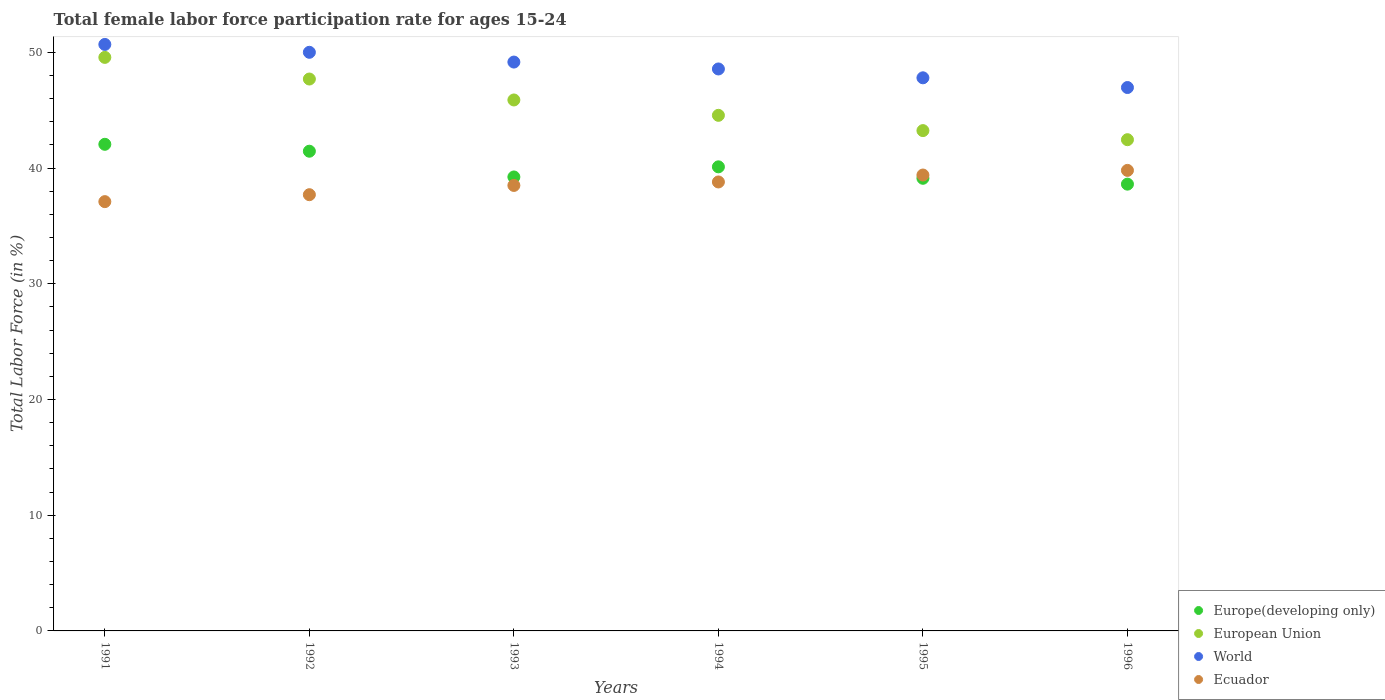What is the female labor force participation rate in Ecuador in 1991?
Offer a terse response. 37.1. Across all years, what is the maximum female labor force participation rate in European Union?
Make the answer very short. 49.57. Across all years, what is the minimum female labor force participation rate in World?
Your answer should be compact. 46.96. What is the total female labor force participation rate in Europe(developing only) in the graph?
Provide a succinct answer. 240.58. What is the difference between the female labor force participation rate in European Union in 1991 and that in 1992?
Make the answer very short. 1.87. What is the difference between the female labor force participation rate in Ecuador in 1993 and the female labor force participation rate in Europe(developing only) in 1994?
Provide a succinct answer. -1.61. What is the average female labor force participation rate in European Union per year?
Provide a short and direct response. 45.57. In the year 1992, what is the difference between the female labor force participation rate in European Union and female labor force participation rate in World?
Keep it short and to the point. -2.31. What is the ratio of the female labor force participation rate in World in 1995 to that in 1996?
Your answer should be compact. 1.02. What is the difference between the highest and the second highest female labor force participation rate in World?
Your answer should be very brief. 0.68. What is the difference between the highest and the lowest female labor force participation rate in European Union?
Give a very brief answer. 7.11. Is it the case that in every year, the sum of the female labor force participation rate in Ecuador and female labor force participation rate in Europe(developing only)  is greater than the sum of female labor force participation rate in World and female labor force participation rate in European Union?
Provide a short and direct response. No. Is it the case that in every year, the sum of the female labor force participation rate in Ecuador and female labor force participation rate in World  is greater than the female labor force participation rate in European Union?
Ensure brevity in your answer.  Yes. Does the female labor force participation rate in European Union monotonically increase over the years?
Your response must be concise. No. Is the female labor force participation rate in World strictly greater than the female labor force participation rate in Ecuador over the years?
Your answer should be compact. Yes. How many dotlines are there?
Ensure brevity in your answer.  4. How many years are there in the graph?
Provide a succinct answer. 6. What is the difference between two consecutive major ticks on the Y-axis?
Ensure brevity in your answer.  10. Does the graph contain any zero values?
Provide a succinct answer. No. How many legend labels are there?
Your answer should be very brief. 4. What is the title of the graph?
Your answer should be very brief. Total female labor force participation rate for ages 15-24. What is the Total Labor Force (in %) in Europe(developing only) in 1991?
Provide a short and direct response. 42.05. What is the Total Labor Force (in %) in European Union in 1991?
Offer a terse response. 49.57. What is the Total Labor Force (in %) in World in 1991?
Your answer should be very brief. 50.69. What is the Total Labor Force (in %) in Ecuador in 1991?
Offer a very short reply. 37.1. What is the Total Labor Force (in %) of Europe(developing only) in 1992?
Your response must be concise. 41.46. What is the Total Labor Force (in %) of European Union in 1992?
Keep it short and to the point. 47.7. What is the Total Labor Force (in %) of World in 1992?
Offer a very short reply. 50.01. What is the Total Labor Force (in %) of Ecuador in 1992?
Keep it short and to the point. 37.7. What is the Total Labor Force (in %) of Europe(developing only) in 1993?
Provide a succinct answer. 39.23. What is the Total Labor Force (in %) of European Union in 1993?
Make the answer very short. 45.89. What is the Total Labor Force (in %) of World in 1993?
Offer a very short reply. 49.16. What is the Total Labor Force (in %) of Ecuador in 1993?
Offer a very short reply. 38.5. What is the Total Labor Force (in %) in Europe(developing only) in 1994?
Give a very brief answer. 40.11. What is the Total Labor Force (in %) of European Union in 1994?
Your answer should be very brief. 44.56. What is the Total Labor Force (in %) in World in 1994?
Your answer should be very brief. 48.57. What is the Total Labor Force (in %) in Ecuador in 1994?
Give a very brief answer. 38.8. What is the Total Labor Force (in %) of Europe(developing only) in 1995?
Your answer should be very brief. 39.12. What is the Total Labor Force (in %) of European Union in 1995?
Your response must be concise. 43.24. What is the Total Labor Force (in %) of World in 1995?
Ensure brevity in your answer.  47.8. What is the Total Labor Force (in %) of Ecuador in 1995?
Your answer should be compact. 39.4. What is the Total Labor Force (in %) of Europe(developing only) in 1996?
Provide a short and direct response. 38.61. What is the Total Labor Force (in %) in European Union in 1996?
Provide a succinct answer. 42.45. What is the Total Labor Force (in %) in World in 1996?
Provide a succinct answer. 46.96. What is the Total Labor Force (in %) of Ecuador in 1996?
Offer a terse response. 39.8. Across all years, what is the maximum Total Labor Force (in %) of Europe(developing only)?
Give a very brief answer. 42.05. Across all years, what is the maximum Total Labor Force (in %) in European Union?
Provide a succinct answer. 49.57. Across all years, what is the maximum Total Labor Force (in %) in World?
Make the answer very short. 50.69. Across all years, what is the maximum Total Labor Force (in %) of Ecuador?
Offer a very short reply. 39.8. Across all years, what is the minimum Total Labor Force (in %) of Europe(developing only)?
Offer a very short reply. 38.61. Across all years, what is the minimum Total Labor Force (in %) of European Union?
Provide a short and direct response. 42.45. Across all years, what is the minimum Total Labor Force (in %) in World?
Ensure brevity in your answer.  46.96. Across all years, what is the minimum Total Labor Force (in %) of Ecuador?
Your answer should be very brief. 37.1. What is the total Total Labor Force (in %) of Europe(developing only) in the graph?
Keep it short and to the point. 240.58. What is the total Total Labor Force (in %) of European Union in the graph?
Your response must be concise. 273.4. What is the total Total Labor Force (in %) of World in the graph?
Your response must be concise. 293.18. What is the total Total Labor Force (in %) of Ecuador in the graph?
Provide a short and direct response. 231.3. What is the difference between the Total Labor Force (in %) in Europe(developing only) in 1991 and that in 1992?
Your answer should be very brief. 0.6. What is the difference between the Total Labor Force (in %) of European Union in 1991 and that in 1992?
Your answer should be compact. 1.87. What is the difference between the Total Labor Force (in %) of World in 1991 and that in 1992?
Offer a very short reply. 0.68. What is the difference between the Total Labor Force (in %) in Europe(developing only) in 1991 and that in 1993?
Ensure brevity in your answer.  2.82. What is the difference between the Total Labor Force (in %) in European Union in 1991 and that in 1993?
Give a very brief answer. 3.68. What is the difference between the Total Labor Force (in %) of World in 1991 and that in 1993?
Ensure brevity in your answer.  1.52. What is the difference between the Total Labor Force (in %) of Europe(developing only) in 1991 and that in 1994?
Make the answer very short. 1.95. What is the difference between the Total Labor Force (in %) in European Union in 1991 and that in 1994?
Your answer should be compact. 5.01. What is the difference between the Total Labor Force (in %) of World in 1991 and that in 1994?
Ensure brevity in your answer.  2.12. What is the difference between the Total Labor Force (in %) in Europe(developing only) in 1991 and that in 1995?
Offer a very short reply. 2.94. What is the difference between the Total Labor Force (in %) in European Union in 1991 and that in 1995?
Provide a short and direct response. 6.33. What is the difference between the Total Labor Force (in %) of World in 1991 and that in 1995?
Keep it short and to the point. 2.88. What is the difference between the Total Labor Force (in %) in Europe(developing only) in 1991 and that in 1996?
Offer a terse response. 3.44. What is the difference between the Total Labor Force (in %) of European Union in 1991 and that in 1996?
Offer a very short reply. 7.11. What is the difference between the Total Labor Force (in %) of World in 1991 and that in 1996?
Provide a succinct answer. 3.72. What is the difference between the Total Labor Force (in %) in Ecuador in 1991 and that in 1996?
Make the answer very short. -2.7. What is the difference between the Total Labor Force (in %) in Europe(developing only) in 1992 and that in 1993?
Provide a succinct answer. 2.23. What is the difference between the Total Labor Force (in %) in European Union in 1992 and that in 1993?
Ensure brevity in your answer.  1.81. What is the difference between the Total Labor Force (in %) in World in 1992 and that in 1993?
Your answer should be compact. 0.84. What is the difference between the Total Labor Force (in %) in Europe(developing only) in 1992 and that in 1994?
Your answer should be compact. 1.35. What is the difference between the Total Labor Force (in %) of European Union in 1992 and that in 1994?
Provide a short and direct response. 3.14. What is the difference between the Total Labor Force (in %) of World in 1992 and that in 1994?
Your response must be concise. 1.44. What is the difference between the Total Labor Force (in %) of Ecuador in 1992 and that in 1994?
Offer a very short reply. -1.1. What is the difference between the Total Labor Force (in %) in Europe(developing only) in 1992 and that in 1995?
Your response must be concise. 2.34. What is the difference between the Total Labor Force (in %) of European Union in 1992 and that in 1995?
Offer a terse response. 4.46. What is the difference between the Total Labor Force (in %) of World in 1992 and that in 1995?
Ensure brevity in your answer.  2.2. What is the difference between the Total Labor Force (in %) of Europe(developing only) in 1992 and that in 1996?
Your response must be concise. 2.85. What is the difference between the Total Labor Force (in %) in European Union in 1992 and that in 1996?
Your answer should be compact. 5.24. What is the difference between the Total Labor Force (in %) of World in 1992 and that in 1996?
Your answer should be very brief. 3.04. What is the difference between the Total Labor Force (in %) in Ecuador in 1992 and that in 1996?
Make the answer very short. -2.1. What is the difference between the Total Labor Force (in %) in Europe(developing only) in 1993 and that in 1994?
Your answer should be very brief. -0.87. What is the difference between the Total Labor Force (in %) of European Union in 1993 and that in 1994?
Ensure brevity in your answer.  1.33. What is the difference between the Total Labor Force (in %) in World in 1993 and that in 1994?
Your answer should be compact. 0.6. What is the difference between the Total Labor Force (in %) of Europe(developing only) in 1993 and that in 1995?
Give a very brief answer. 0.11. What is the difference between the Total Labor Force (in %) in European Union in 1993 and that in 1995?
Ensure brevity in your answer.  2.65. What is the difference between the Total Labor Force (in %) of World in 1993 and that in 1995?
Provide a short and direct response. 1.36. What is the difference between the Total Labor Force (in %) of Ecuador in 1993 and that in 1995?
Your answer should be very brief. -0.9. What is the difference between the Total Labor Force (in %) in Europe(developing only) in 1993 and that in 1996?
Provide a succinct answer. 0.62. What is the difference between the Total Labor Force (in %) of European Union in 1993 and that in 1996?
Provide a succinct answer. 3.43. What is the difference between the Total Labor Force (in %) in World in 1993 and that in 1996?
Make the answer very short. 2.2. What is the difference between the Total Labor Force (in %) in Ecuador in 1993 and that in 1996?
Provide a short and direct response. -1.3. What is the difference between the Total Labor Force (in %) of European Union in 1994 and that in 1995?
Offer a terse response. 1.32. What is the difference between the Total Labor Force (in %) in World in 1994 and that in 1995?
Your answer should be very brief. 0.76. What is the difference between the Total Labor Force (in %) of Europe(developing only) in 1994 and that in 1996?
Provide a succinct answer. 1.5. What is the difference between the Total Labor Force (in %) in European Union in 1994 and that in 1996?
Ensure brevity in your answer.  2.11. What is the difference between the Total Labor Force (in %) of World in 1994 and that in 1996?
Ensure brevity in your answer.  1.6. What is the difference between the Total Labor Force (in %) in Ecuador in 1994 and that in 1996?
Make the answer very short. -1. What is the difference between the Total Labor Force (in %) in Europe(developing only) in 1995 and that in 1996?
Make the answer very short. 0.51. What is the difference between the Total Labor Force (in %) of European Union in 1995 and that in 1996?
Offer a very short reply. 0.79. What is the difference between the Total Labor Force (in %) of World in 1995 and that in 1996?
Provide a succinct answer. 0.84. What is the difference between the Total Labor Force (in %) in Europe(developing only) in 1991 and the Total Labor Force (in %) in European Union in 1992?
Keep it short and to the point. -5.64. What is the difference between the Total Labor Force (in %) of Europe(developing only) in 1991 and the Total Labor Force (in %) of World in 1992?
Ensure brevity in your answer.  -7.95. What is the difference between the Total Labor Force (in %) in Europe(developing only) in 1991 and the Total Labor Force (in %) in Ecuador in 1992?
Keep it short and to the point. 4.35. What is the difference between the Total Labor Force (in %) in European Union in 1991 and the Total Labor Force (in %) in World in 1992?
Offer a very short reply. -0.44. What is the difference between the Total Labor Force (in %) in European Union in 1991 and the Total Labor Force (in %) in Ecuador in 1992?
Keep it short and to the point. 11.87. What is the difference between the Total Labor Force (in %) in World in 1991 and the Total Labor Force (in %) in Ecuador in 1992?
Provide a short and direct response. 12.99. What is the difference between the Total Labor Force (in %) in Europe(developing only) in 1991 and the Total Labor Force (in %) in European Union in 1993?
Keep it short and to the point. -3.83. What is the difference between the Total Labor Force (in %) of Europe(developing only) in 1991 and the Total Labor Force (in %) of World in 1993?
Your answer should be compact. -7.11. What is the difference between the Total Labor Force (in %) of Europe(developing only) in 1991 and the Total Labor Force (in %) of Ecuador in 1993?
Offer a terse response. 3.55. What is the difference between the Total Labor Force (in %) of European Union in 1991 and the Total Labor Force (in %) of World in 1993?
Offer a very short reply. 0.4. What is the difference between the Total Labor Force (in %) of European Union in 1991 and the Total Labor Force (in %) of Ecuador in 1993?
Offer a very short reply. 11.07. What is the difference between the Total Labor Force (in %) of World in 1991 and the Total Labor Force (in %) of Ecuador in 1993?
Ensure brevity in your answer.  12.19. What is the difference between the Total Labor Force (in %) of Europe(developing only) in 1991 and the Total Labor Force (in %) of European Union in 1994?
Give a very brief answer. -2.5. What is the difference between the Total Labor Force (in %) in Europe(developing only) in 1991 and the Total Labor Force (in %) in World in 1994?
Make the answer very short. -6.51. What is the difference between the Total Labor Force (in %) in Europe(developing only) in 1991 and the Total Labor Force (in %) in Ecuador in 1994?
Your response must be concise. 3.25. What is the difference between the Total Labor Force (in %) of European Union in 1991 and the Total Labor Force (in %) of Ecuador in 1994?
Provide a succinct answer. 10.77. What is the difference between the Total Labor Force (in %) of World in 1991 and the Total Labor Force (in %) of Ecuador in 1994?
Provide a short and direct response. 11.89. What is the difference between the Total Labor Force (in %) in Europe(developing only) in 1991 and the Total Labor Force (in %) in European Union in 1995?
Keep it short and to the point. -1.18. What is the difference between the Total Labor Force (in %) of Europe(developing only) in 1991 and the Total Labor Force (in %) of World in 1995?
Keep it short and to the point. -5.75. What is the difference between the Total Labor Force (in %) in Europe(developing only) in 1991 and the Total Labor Force (in %) in Ecuador in 1995?
Ensure brevity in your answer.  2.65. What is the difference between the Total Labor Force (in %) of European Union in 1991 and the Total Labor Force (in %) of World in 1995?
Offer a very short reply. 1.77. What is the difference between the Total Labor Force (in %) of European Union in 1991 and the Total Labor Force (in %) of Ecuador in 1995?
Your response must be concise. 10.17. What is the difference between the Total Labor Force (in %) in World in 1991 and the Total Labor Force (in %) in Ecuador in 1995?
Your answer should be very brief. 11.29. What is the difference between the Total Labor Force (in %) of Europe(developing only) in 1991 and the Total Labor Force (in %) of European Union in 1996?
Offer a terse response. -0.4. What is the difference between the Total Labor Force (in %) of Europe(developing only) in 1991 and the Total Labor Force (in %) of World in 1996?
Provide a short and direct response. -4.91. What is the difference between the Total Labor Force (in %) of Europe(developing only) in 1991 and the Total Labor Force (in %) of Ecuador in 1996?
Give a very brief answer. 2.25. What is the difference between the Total Labor Force (in %) of European Union in 1991 and the Total Labor Force (in %) of World in 1996?
Your response must be concise. 2.6. What is the difference between the Total Labor Force (in %) of European Union in 1991 and the Total Labor Force (in %) of Ecuador in 1996?
Ensure brevity in your answer.  9.77. What is the difference between the Total Labor Force (in %) in World in 1991 and the Total Labor Force (in %) in Ecuador in 1996?
Provide a succinct answer. 10.89. What is the difference between the Total Labor Force (in %) of Europe(developing only) in 1992 and the Total Labor Force (in %) of European Union in 1993?
Offer a very short reply. -4.43. What is the difference between the Total Labor Force (in %) in Europe(developing only) in 1992 and the Total Labor Force (in %) in World in 1993?
Offer a terse response. -7.7. What is the difference between the Total Labor Force (in %) of Europe(developing only) in 1992 and the Total Labor Force (in %) of Ecuador in 1993?
Give a very brief answer. 2.96. What is the difference between the Total Labor Force (in %) of European Union in 1992 and the Total Labor Force (in %) of World in 1993?
Provide a succinct answer. -1.47. What is the difference between the Total Labor Force (in %) of European Union in 1992 and the Total Labor Force (in %) of Ecuador in 1993?
Ensure brevity in your answer.  9.2. What is the difference between the Total Labor Force (in %) of World in 1992 and the Total Labor Force (in %) of Ecuador in 1993?
Make the answer very short. 11.51. What is the difference between the Total Labor Force (in %) in Europe(developing only) in 1992 and the Total Labor Force (in %) in European Union in 1994?
Offer a very short reply. -3.1. What is the difference between the Total Labor Force (in %) of Europe(developing only) in 1992 and the Total Labor Force (in %) of World in 1994?
Provide a succinct answer. -7.11. What is the difference between the Total Labor Force (in %) of Europe(developing only) in 1992 and the Total Labor Force (in %) of Ecuador in 1994?
Offer a terse response. 2.66. What is the difference between the Total Labor Force (in %) of European Union in 1992 and the Total Labor Force (in %) of World in 1994?
Offer a terse response. -0.87. What is the difference between the Total Labor Force (in %) of European Union in 1992 and the Total Labor Force (in %) of Ecuador in 1994?
Provide a succinct answer. 8.9. What is the difference between the Total Labor Force (in %) in World in 1992 and the Total Labor Force (in %) in Ecuador in 1994?
Ensure brevity in your answer.  11.21. What is the difference between the Total Labor Force (in %) of Europe(developing only) in 1992 and the Total Labor Force (in %) of European Union in 1995?
Ensure brevity in your answer.  -1.78. What is the difference between the Total Labor Force (in %) in Europe(developing only) in 1992 and the Total Labor Force (in %) in World in 1995?
Keep it short and to the point. -6.34. What is the difference between the Total Labor Force (in %) in Europe(developing only) in 1992 and the Total Labor Force (in %) in Ecuador in 1995?
Your answer should be compact. 2.06. What is the difference between the Total Labor Force (in %) of European Union in 1992 and the Total Labor Force (in %) of World in 1995?
Your answer should be very brief. -0.1. What is the difference between the Total Labor Force (in %) of European Union in 1992 and the Total Labor Force (in %) of Ecuador in 1995?
Provide a short and direct response. 8.3. What is the difference between the Total Labor Force (in %) of World in 1992 and the Total Labor Force (in %) of Ecuador in 1995?
Give a very brief answer. 10.61. What is the difference between the Total Labor Force (in %) in Europe(developing only) in 1992 and the Total Labor Force (in %) in European Union in 1996?
Your answer should be compact. -1. What is the difference between the Total Labor Force (in %) of Europe(developing only) in 1992 and the Total Labor Force (in %) of World in 1996?
Your answer should be compact. -5.5. What is the difference between the Total Labor Force (in %) in Europe(developing only) in 1992 and the Total Labor Force (in %) in Ecuador in 1996?
Provide a short and direct response. 1.66. What is the difference between the Total Labor Force (in %) in European Union in 1992 and the Total Labor Force (in %) in World in 1996?
Offer a very short reply. 0.73. What is the difference between the Total Labor Force (in %) in European Union in 1992 and the Total Labor Force (in %) in Ecuador in 1996?
Ensure brevity in your answer.  7.9. What is the difference between the Total Labor Force (in %) of World in 1992 and the Total Labor Force (in %) of Ecuador in 1996?
Offer a very short reply. 10.21. What is the difference between the Total Labor Force (in %) in Europe(developing only) in 1993 and the Total Labor Force (in %) in European Union in 1994?
Provide a succinct answer. -5.33. What is the difference between the Total Labor Force (in %) in Europe(developing only) in 1993 and the Total Labor Force (in %) in World in 1994?
Provide a short and direct response. -9.33. What is the difference between the Total Labor Force (in %) in Europe(developing only) in 1993 and the Total Labor Force (in %) in Ecuador in 1994?
Ensure brevity in your answer.  0.43. What is the difference between the Total Labor Force (in %) of European Union in 1993 and the Total Labor Force (in %) of World in 1994?
Make the answer very short. -2.68. What is the difference between the Total Labor Force (in %) of European Union in 1993 and the Total Labor Force (in %) of Ecuador in 1994?
Make the answer very short. 7.09. What is the difference between the Total Labor Force (in %) of World in 1993 and the Total Labor Force (in %) of Ecuador in 1994?
Your response must be concise. 10.36. What is the difference between the Total Labor Force (in %) in Europe(developing only) in 1993 and the Total Labor Force (in %) in European Union in 1995?
Provide a succinct answer. -4.01. What is the difference between the Total Labor Force (in %) of Europe(developing only) in 1993 and the Total Labor Force (in %) of World in 1995?
Make the answer very short. -8.57. What is the difference between the Total Labor Force (in %) in Europe(developing only) in 1993 and the Total Labor Force (in %) in Ecuador in 1995?
Your answer should be compact. -0.17. What is the difference between the Total Labor Force (in %) of European Union in 1993 and the Total Labor Force (in %) of World in 1995?
Keep it short and to the point. -1.91. What is the difference between the Total Labor Force (in %) in European Union in 1993 and the Total Labor Force (in %) in Ecuador in 1995?
Offer a very short reply. 6.49. What is the difference between the Total Labor Force (in %) in World in 1993 and the Total Labor Force (in %) in Ecuador in 1995?
Your answer should be very brief. 9.76. What is the difference between the Total Labor Force (in %) in Europe(developing only) in 1993 and the Total Labor Force (in %) in European Union in 1996?
Your answer should be very brief. -3.22. What is the difference between the Total Labor Force (in %) in Europe(developing only) in 1993 and the Total Labor Force (in %) in World in 1996?
Offer a very short reply. -7.73. What is the difference between the Total Labor Force (in %) of Europe(developing only) in 1993 and the Total Labor Force (in %) of Ecuador in 1996?
Offer a very short reply. -0.57. What is the difference between the Total Labor Force (in %) of European Union in 1993 and the Total Labor Force (in %) of World in 1996?
Provide a short and direct response. -1.08. What is the difference between the Total Labor Force (in %) of European Union in 1993 and the Total Labor Force (in %) of Ecuador in 1996?
Make the answer very short. 6.09. What is the difference between the Total Labor Force (in %) in World in 1993 and the Total Labor Force (in %) in Ecuador in 1996?
Your answer should be compact. 9.36. What is the difference between the Total Labor Force (in %) of Europe(developing only) in 1994 and the Total Labor Force (in %) of European Union in 1995?
Offer a very short reply. -3.13. What is the difference between the Total Labor Force (in %) in Europe(developing only) in 1994 and the Total Labor Force (in %) in World in 1995?
Ensure brevity in your answer.  -7.69. What is the difference between the Total Labor Force (in %) in Europe(developing only) in 1994 and the Total Labor Force (in %) in Ecuador in 1995?
Give a very brief answer. 0.71. What is the difference between the Total Labor Force (in %) in European Union in 1994 and the Total Labor Force (in %) in World in 1995?
Offer a terse response. -3.24. What is the difference between the Total Labor Force (in %) of European Union in 1994 and the Total Labor Force (in %) of Ecuador in 1995?
Provide a short and direct response. 5.16. What is the difference between the Total Labor Force (in %) in World in 1994 and the Total Labor Force (in %) in Ecuador in 1995?
Provide a succinct answer. 9.17. What is the difference between the Total Labor Force (in %) of Europe(developing only) in 1994 and the Total Labor Force (in %) of European Union in 1996?
Keep it short and to the point. -2.35. What is the difference between the Total Labor Force (in %) in Europe(developing only) in 1994 and the Total Labor Force (in %) in World in 1996?
Your answer should be compact. -6.85. What is the difference between the Total Labor Force (in %) of Europe(developing only) in 1994 and the Total Labor Force (in %) of Ecuador in 1996?
Provide a succinct answer. 0.31. What is the difference between the Total Labor Force (in %) of European Union in 1994 and the Total Labor Force (in %) of World in 1996?
Provide a succinct answer. -2.4. What is the difference between the Total Labor Force (in %) of European Union in 1994 and the Total Labor Force (in %) of Ecuador in 1996?
Keep it short and to the point. 4.76. What is the difference between the Total Labor Force (in %) of World in 1994 and the Total Labor Force (in %) of Ecuador in 1996?
Your answer should be very brief. 8.77. What is the difference between the Total Labor Force (in %) in Europe(developing only) in 1995 and the Total Labor Force (in %) in European Union in 1996?
Make the answer very short. -3.33. What is the difference between the Total Labor Force (in %) of Europe(developing only) in 1995 and the Total Labor Force (in %) of World in 1996?
Offer a very short reply. -7.84. What is the difference between the Total Labor Force (in %) in Europe(developing only) in 1995 and the Total Labor Force (in %) in Ecuador in 1996?
Your answer should be very brief. -0.68. What is the difference between the Total Labor Force (in %) of European Union in 1995 and the Total Labor Force (in %) of World in 1996?
Give a very brief answer. -3.72. What is the difference between the Total Labor Force (in %) in European Union in 1995 and the Total Labor Force (in %) in Ecuador in 1996?
Provide a succinct answer. 3.44. What is the difference between the Total Labor Force (in %) of World in 1995 and the Total Labor Force (in %) of Ecuador in 1996?
Make the answer very short. 8. What is the average Total Labor Force (in %) in Europe(developing only) per year?
Offer a terse response. 40.1. What is the average Total Labor Force (in %) of European Union per year?
Provide a short and direct response. 45.57. What is the average Total Labor Force (in %) of World per year?
Your answer should be very brief. 48.86. What is the average Total Labor Force (in %) of Ecuador per year?
Provide a short and direct response. 38.55. In the year 1991, what is the difference between the Total Labor Force (in %) of Europe(developing only) and Total Labor Force (in %) of European Union?
Your answer should be compact. -7.51. In the year 1991, what is the difference between the Total Labor Force (in %) in Europe(developing only) and Total Labor Force (in %) in World?
Offer a very short reply. -8.63. In the year 1991, what is the difference between the Total Labor Force (in %) in Europe(developing only) and Total Labor Force (in %) in Ecuador?
Provide a short and direct response. 4.95. In the year 1991, what is the difference between the Total Labor Force (in %) in European Union and Total Labor Force (in %) in World?
Your answer should be compact. -1.12. In the year 1991, what is the difference between the Total Labor Force (in %) in European Union and Total Labor Force (in %) in Ecuador?
Offer a terse response. 12.47. In the year 1991, what is the difference between the Total Labor Force (in %) in World and Total Labor Force (in %) in Ecuador?
Offer a terse response. 13.59. In the year 1992, what is the difference between the Total Labor Force (in %) of Europe(developing only) and Total Labor Force (in %) of European Union?
Keep it short and to the point. -6.24. In the year 1992, what is the difference between the Total Labor Force (in %) of Europe(developing only) and Total Labor Force (in %) of World?
Your response must be concise. -8.55. In the year 1992, what is the difference between the Total Labor Force (in %) of Europe(developing only) and Total Labor Force (in %) of Ecuador?
Give a very brief answer. 3.76. In the year 1992, what is the difference between the Total Labor Force (in %) of European Union and Total Labor Force (in %) of World?
Offer a very short reply. -2.31. In the year 1992, what is the difference between the Total Labor Force (in %) of European Union and Total Labor Force (in %) of Ecuador?
Ensure brevity in your answer.  10. In the year 1992, what is the difference between the Total Labor Force (in %) of World and Total Labor Force (in %) of Ecuador?
Your response must be concise. 12.31. In the year 1993, what is the difference between the Total Labor Force (in %) in Europe(developing only) and Total Labor Force (in %) in European Union?
Your answer should be compact. -6.65. In the year 1993, what is the difference between the Total Labor Force (in %) of Europe(developing only) and Total Labor Force (in %) of World?
Offer a very short reply. -9.93. In the year 1993, what is the difference between the Total Labor Force (in %) in Europe(developing only) and Total Labor Force (in %) in Ecuador?
Give a very brief answer. 0.73. In the year 1993, what is the difference between the Total Labor Force (in %) in European Union and Total Labor Force (in %) in World?
Your answer should be very brief. -3.28. In the year 1993, what is the difference between the Total Labor Force (in %) in European Union and Total Labor Force (in %) in Ecuador?
Your answer should be compact. 7.39. In the year 1993, what is the difference between the Total Labor Force (in %) in World and Total Labor Force (in %) in Ecuador?
Your answer should be very brief. 10.66. In the year 1994, what is the difference between the Total Labor Force (in %) in Europe(developing only) and Total Labor Force (in %) in European Union?
Make the answer very short. -4.45. In the year 1994, what is the difference between the Total Labor Force (in %) of Europe(developing only) and Total Labor Force (in %) of World?
Provide a succinct answer. -8.46. In the year 1994, what is the difference between the Total Labor Force (in %) of Europe(developing only) and Total Labor Force (in %) of Ecuador?
Your answer should be very brief. 1.31. In the year 1994, what is the difference between the Total Labor Force (in %) in European Union and Total Labor Force (in %) in World?
Offer a very short reply. -4.01. In the year 1994, what is the difference between the Total Labor Force (in %) in European Union and Total Labor Force (in %) in Ecuador?
Your answer should be compact. 5.76. In the year 1994, what is the difference between the Total Labor Force (in %) in World and Total Labor Force (in %) in Ecuador?
Your answer should be compact. 9.77. In the year 1995, what is the difference between the Total Labor Force (in %) in Europe(developing only) and Total Labor Force (in %) in European Union?
Your response must be concise. -4.12. In the year 1995, what is the difference between the Total Labor Force (in %) of Europe(developing only) and Total Labor Force (in %) of World?
Your answer should be compact. -8.68. In the year 1995, what is the difference between the Total Labor Force (in %) of Europe(developing only) and Total Labor Force (in %) of Ecuador?
Give a very brief answer. -0.28. In the year 1995, what is the difference between the Total Labor Force (in %) of European Union and Total Labor Force (in %) of World?
Provide a short and direct response. -4.56. In the year 1995, what is the difference between the Total Labor Force (in %) of European Union and Total Labor Force (in %) of Ecuador?
Give a very brief answer. 3.84. In the year 1995, what is the difference between the Total Labor Force (in %) of World and Total Labor Force (in %) of Ecuador?
Make the answer very short. 8.4. In the year 1996, what is the difference between the Total Labor Force (in %) of Europe(developing only) and Total Labor Force (in %) of European Union?
Ensure brevity in your answer.  -3.84. In the year 1996, what is the difference between the Total Labor Force (in %) of Europe(developing only) and Total Labor Force (in %) of World?
Make the answer very short. -8.35. In the year 1996, what is the difference between the Total Labor Force (in %) of Europe(developing only) and Total Labor Force (in %) of Ecuador?
Your answer should be very brief. -1.19. In the year 1996, what is the difference between the Total Labor Force (in %) in European Union and Total Labor Force (in %) in World?
Offer a very short reply. -4.51. In the year 1996, what is the difference between the Total Labor Force (in %) in European Union and Total Labor Force (in %) in Ecuador?
Give a very brief answer. 2.65. In the year 1996, what is the difference between the Total Labor Force (in %) of World and Total Labor Force (in %) of Ecuador?
Offer a very short reply. 7.16. What is the ratio of the Total Labor Force (in %) in Europe(developing only) in 1991 to that in 1992?
Your answer should be very brief. 1.01. What is the ratio of the Total Labor Force (in %) in European Union in 1991 to that in 1992?
Offer a very short reply. 1.04. What is the ratio of the Total Labor Force (in %) in World in 1991 to that in 1992?
Offer a very short reply. 1.01. What is the ratio of the Total Labor Force (in %) of Ecuador in 1991 to that in 1992?
Your answer should be very brief. 0.98. What is the ratio of the Total Labor Force (in %) in Europe(developing only) in 1991 to that in 1993?
Provide a short and direct response. 1.07. What is the ratio of the Total Labor Force (in %) in European Union in 1991 to that in 1993?
Provide a short and direct response. 1.08. What is the ratio of the Total Labor Force (in %) of World in 1991 to that in 1993?
Ensure brevity in your answer.  1.03. What is the ratio of the Total Labor Force (in %) in Ecuador in 1991 to that in 1993?
Offer a terse response. 0.96. What is the ratio of the Total Labor Force (in %) of Europe(developing only) in 1991 to that in 1994?
Provide a short and direct response. 1.05. What is the ratio of the Total Labor Force (in %) in European Union in 1991 to that in 1994?
Offer a very short reply. 1.11. What is the ratio of the Total Labor Force (in %) in World in 1991 to that in 1994?
Offer a very short reply. 1.04. What is the ratio of the Total Labor Force (in %) in Ecuador in 1991 to that in 1994?
Your answer should be very brief. 0.96. What is the ratio of the Total Labor Force (in %) in Europe(developing only) in 1991 to that in 1995?
Offer a very short reply. 1.08. What is the ratio of the Total Labor Force (in %) of European Union in 1991 to that in 1995?
Give a very brief answer. 1.15. What is the ratio of the Total Labor Force (in %) in World in 1991 to that in 1995?
Make the answer very short. 1.06. What is the ratio of the Total Labor Force (in %) of Ecuador in 1991 to that in 1995?
Provide a succinct answer. 0.94. What is the ratio of the Total Labor Force (in %) in Europe(developing only) in 1991 to that in 1996?
Offer a very short reply. 1.09. What is the ratio of the Total Labor Force (in %) in European Union in 1991 to that in 1996?
Your answer should be compact. 1.17. What is the ratio of the Total Labor Force (in %) of World in 1991 to that in 1996?
Offer a very short reply. 1.08. What is the ratio of the Total Labor Force (in %) of Ecuador in 1991 to that in 1996?
Make the answer very short. 0.93. What is the ratio of the Total Labor Force (in %) of Europe(developing only) in 1992 to that in 1993?
Your response must be concise. 1.06. What is the ratio of the Total Labor Force (in %) of European Union in 1992 to that in 1993?
Ensure brevity in your answer.  1.04. What is the ratio of the Total Labor Force (in %) of World in 1992 to that in 1993?
Ensure brevity in your answer.  1.02. What is the ratio of the Total Labor Force (in %) in Ecuador in 1992 to that in 1993?
Provide a short and direct response. 0.98. What is the ratio of the Total Labor Force (in %) in Europe(developing only) in 1992 to that in 1994?
Your response must be concise. 1.03. What is the ratio of the Total Labor Force (in %) of European Union in 1992 to that in 1994?
Provide a short and direct response. 1.07. What is the ratio of the Total Labor Force (in %) of World in 1992 to that in 1994?
Provide a short and direct response. 1.03. What is the ratio of the Total Labor Force (in %) in Ecuador in 1992 to that in 1994?
Ensure brevity in your answer.  0.97. What is the ratio of the Total Labor Force (in %) in Europe(developing only) in 1992 to that in 1995?
Offer a very short reply. 1.06. What is the ratio of the Total Labor Force (in %) in European Union in 1992 to that in 1995?
Give a very brief answer. 1.1. What is the ratio of the Total Labor Force (in %) in World in 1992 to that in 1995?
Your answer should be compact. 1.05. What is the ratio of the Total Labor Force (in %) in Ecuador in 1992 to that in 1995?
Offer a very short reply. 0.96. What is the ratio of the Total Labor Force (in %) in Europe(developing only) in 1992 to that in 1996?
Provide a short and direct response. 1.07. What is the ratio of the Total Labor Force (in %) of European Union in 1992 to that in 1996?
Provide a succinct answer. 1.12. What is the ratio of the Total Labor Force (in %) of World in 1992 to that in 1996?
Offer a terse response. 1.06. What is the ratio of the Total Labor Force (in %) in Ecuador in 1992 to that in 1996?
Your answer should be very brief. 0.95. What is the ratio of the Total Labor Force (in %) of Europe(developing only) in 1993 to that in 1994?
Offer a very short reply. 0.98. What is the ratio of the Total Labor Force (in %) in European Union in 1993 to that in 1994?
Your answer should be compact. 1.03. What is the ratio of the Total Labor Force (in %) of World in 1993 to that in 1994?
Keep it short and to the point. 1.01. What is the ratio of the Total Labor Force (in %) of European Union in 1993 to that in 1995?
Provide a succinct answer. 1.06. What is the ratio of the Total Labor Force (in %) in World in 1993 to that in 1995?
Provide a succinct answer. 1.03. What is the ratio of the Total Labor Force (in %) in Ecuador in 1993 to that in 1995?
Your response must be concise. 0.98. What is the ratio of the Total Labor Force (in %) in Europe(developing only) in 1993 to that in 1996?
Provide a succinct answer. 1.02. What is the ratio of the Total Labor Force (in %) in European Union in 1993 to that in 1996?
Ensure brevity in your answer.  1.08. What is the ratio of the Total Labor Force (in %) in World in 1993 to that in 1996?
Your answer should be very brief. 1.05. What is the ratio of the Total Labor Force (in %) of Ecuador in 1993 to that in 1996?
Provide a succinct answer. 0.97. What is the ratio of the Total Labor Force (in %) of Europe(developing only) in 1994 to that in 1995?
Your answer should be very brief. 1.03. What is the ratio of the Total Labor Force (in %) of European Union in 1994 to that in 1995?
Ensure brevity in your answer.  1.03. What is the ratio of the Total Labor Force (in %) of Ecuador in 1994 to that in 1995?
Offer a terse response. 0.98. What is the ratio of the Total Labor Force (in %) in Europe(developing only) in 1994 to that in 1996?
Offer a terse response. 1.04. What is the ratio of the Total Labor Force (in %) in European Union in 1994 to that in 1996?
Give a very brief answer. 1.05. What is the ratio of the Total Labor Force (in %) of World in 1994 to that in 1996?
Ensure brevity in your answer.  1.03. What is the ratio of the Total Labor Force (in %) of Ecuador in 1994 to that in 1996?
Your response must be concise. 0.97. What is the ratio of the Total Labor Force (in %) of Europe(developing only) in 1995 to that in 1996?
Ensure brevity in your answer.  1.01. What is the ratio of the Total Labor Force (in %) of European Union in 1995 to that in 1996?
Your answer should be very brief. 1.02. What is the ratio of the Total Labor Force (in %) of World in 1995 to that in 1996?
Provide a short and direct response. 1.02. What is the ratio of the Total Labor Force (in %) of Ecuador in 1995 to that in 1996?
Provide a succinct answer. 0.99. What is the difference between the highest and the second highest Total Labor Force (in %) of Europe(developing only)?
Provide a short and direct response. 0.6. What is the difference between the highest and the second highest Total Labor Force (in %) in European Union?
Ensure brevity in your answer.  1.87. What is the difference between the highest and the second highest Total Labor Force (in %) in World?
Your response must be concise. 0.68. What is the difference between the highest and the lowest Total Labor Force (in %) in Europe(developing only)?
Your answer should be very brief. 3.44. What is the difference between the highest and the lowest Total Labor Force (in %) of European Union?
Offer a terse response. 7.11. What is the difference between the highest and the lowest Total Labor Force (in %) in World?
Offer a terse response. 3.72. What is the difference between the highest and the lowest Total Labor Force (in %) of Ecuador?
Your response must be concise. 2.7. 